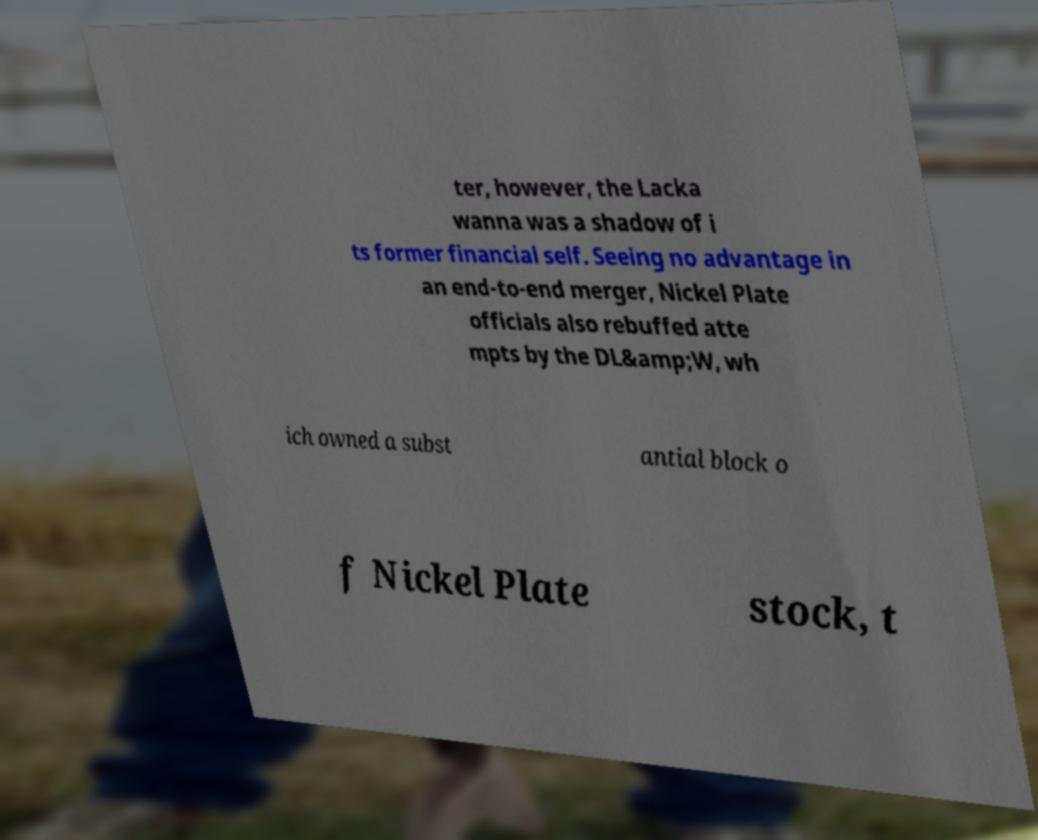There's text embedded in this image that I need extracted. Can you transcribe it verbatim? ter, however, the Lacka wanna was a shadow of i ts former financial self. Seeing no advantage in an end-to-end merger, Nickel Plate officials also rebuffed atte mpts by the DL&amp;W, wh ich owned a subst antial block o f Nickel Plate stock, t 